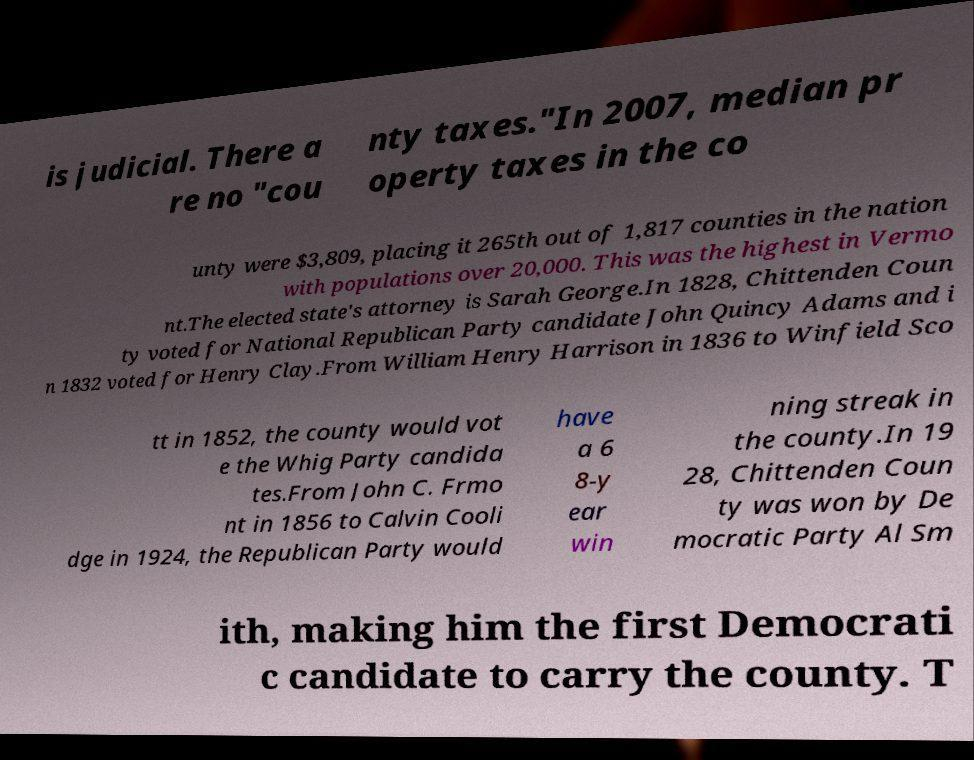There's text embedded in this image that I need extracted. Can you transcribe it verbatim? is judicial. There a re no "cou nty taxes."In 2007, median pr operty taxes in the co unty were $3,809, placing it 265th out of 1,817 counties in the nation with populations over 20,000. This was the highest in Vermo nt.The elected state's attorney is Sarah George.In 1828, Chittenden Coun ty voted for National Republican Party candidate John Quincy Adams and i n 1832 voted for Henry Clay.From William Henry Harrison in 1836 to Winfield Sco tt in 1852, the county would vot e the Whig Party candida tes.From John C. Frmo nt in 1856 to Calvin Cooli dge in 1924, the Republican Party would have a 6 8-y ear win ning streak in the county.In 19 28, Chittenden Coun ty was won by De mocratic Party Al Sm ith, making him the first Democrati c candidate to carry the county. T 